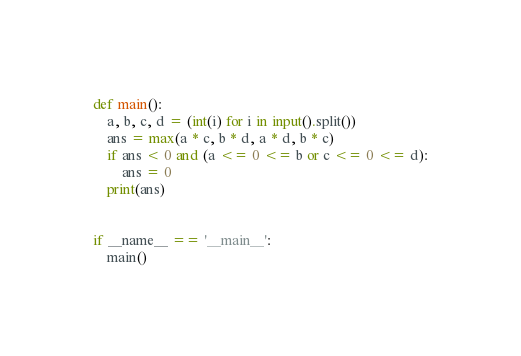Convert code to text. <code><loc_0><loc_0><loc_500><loc_500><_Python_>def main():
    a, b, c, d = (int(i) for i in input().split())
    ans = max(a * c, b * d, a * d, b * c)
    if ans < 0 and (a <= 0 <= b or c <= 0 <= d):
        ans = 0
    print(ans)


if __name__ == '__main__':
    main()
</code> 